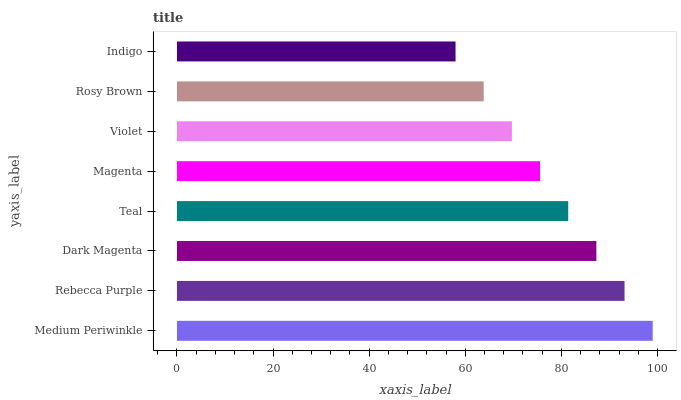Is Indigo the minimum?
Answer yes or no. Yes. Is Medium Periwinkle the maximum?
Answer yes or no. Yes. Is Rebecca Purple the minimum?
Answer yes or no. No. Is Rebecca Purple the maximum?
Answer yes or no. No. Is Medium Periwinkle greater than Rebecca Purple?
Answer yes or no. Yes. Is Rebecca Purple less than Medium Periwinkle?
Answer yes or no. Yes. Is Rebecca Purple greater than Medium Periwinkle?
Answer yes or no. No. Is Medium Periwinkle less than Rebecca Purple?
Answer yes or no. No. Is Teal the high median?
Answer yes or no. Yes. Is Magenta the low median?
Answer yes or no. Yes. Is Dark Magenta the high median?
Answer yes or no. No. Is Medium Periwinkle the low median?
Answer yes or no. No. 